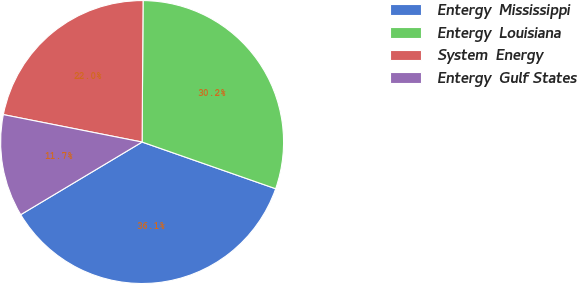<chart> <loc_0><loc_0><loc_500><loc_500><pie_chart><fcel>Entergy  Mississippi<fcel>Entergy  Louisiana<fcel>System  Energy<fcel>Entergy  Gulf States<nl><fcel>36.07%<fcel>30.25%<fcel>22.0%<fcel>11.69%<nl></chart> 